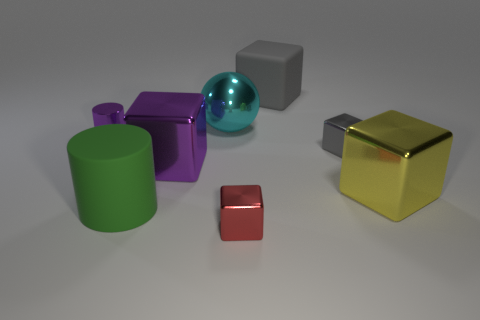How many gray blocks must be subtracted to get 1 gray blocks? 1 Subtract 1 blocks. How many blocks are left? 4 Subtract all yellow metal blocks. How many blocks are left? 4 Subtract all yellow cubes. How many cubes are left? 4 Subtract all cyan blocks. Subtract all brown spheres. How many blocks are left? 5 Add 2 tiny purple shiny things. How many objects exist? 10 Subtract all balls. How many objects are left? 7 Add 5 large matte objects. How many large matte objects are left? 7 Add 6 red things. How many red things exist? 7 Subtract 1 purple cylinders. How many objects are left? 7 